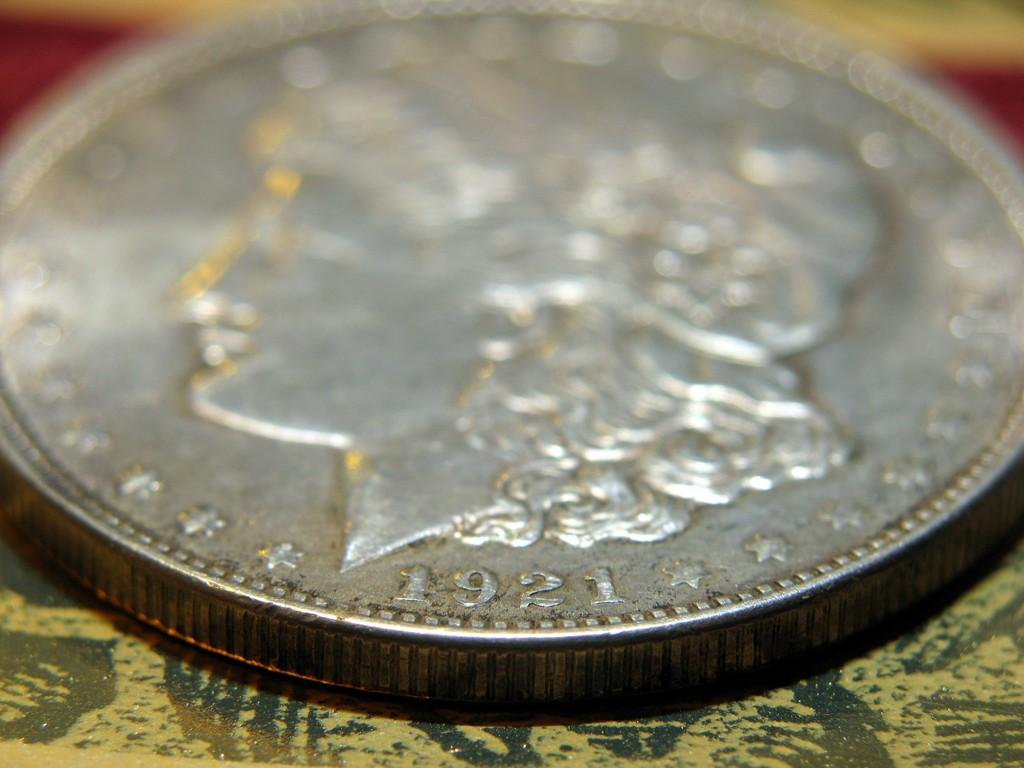<image>
Share a concise interpretation of the image provided. The face of a silver coin with a date of 1921. 